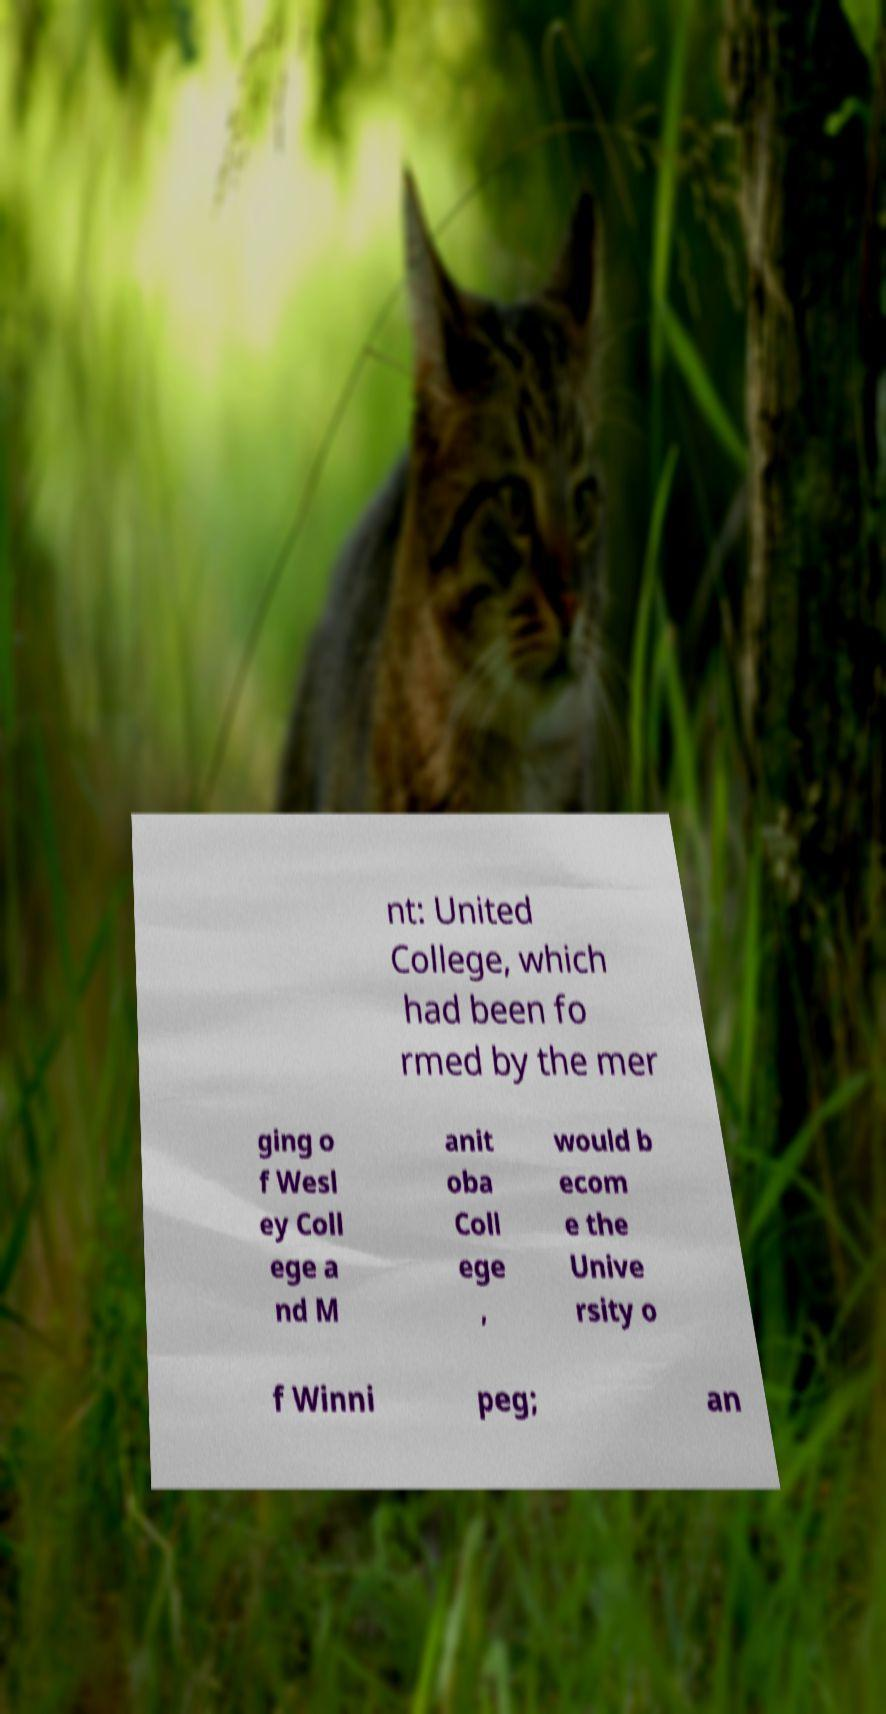There's text embedded in this image that I need extracted. Can you transcribe it verbatim? nt: United College, which had been fo rmed by the mer ging o f Wesl ey Coll ege a nd M anit oba Coll ege , would b ecom e the Unive rsity o f Winni peg; an 